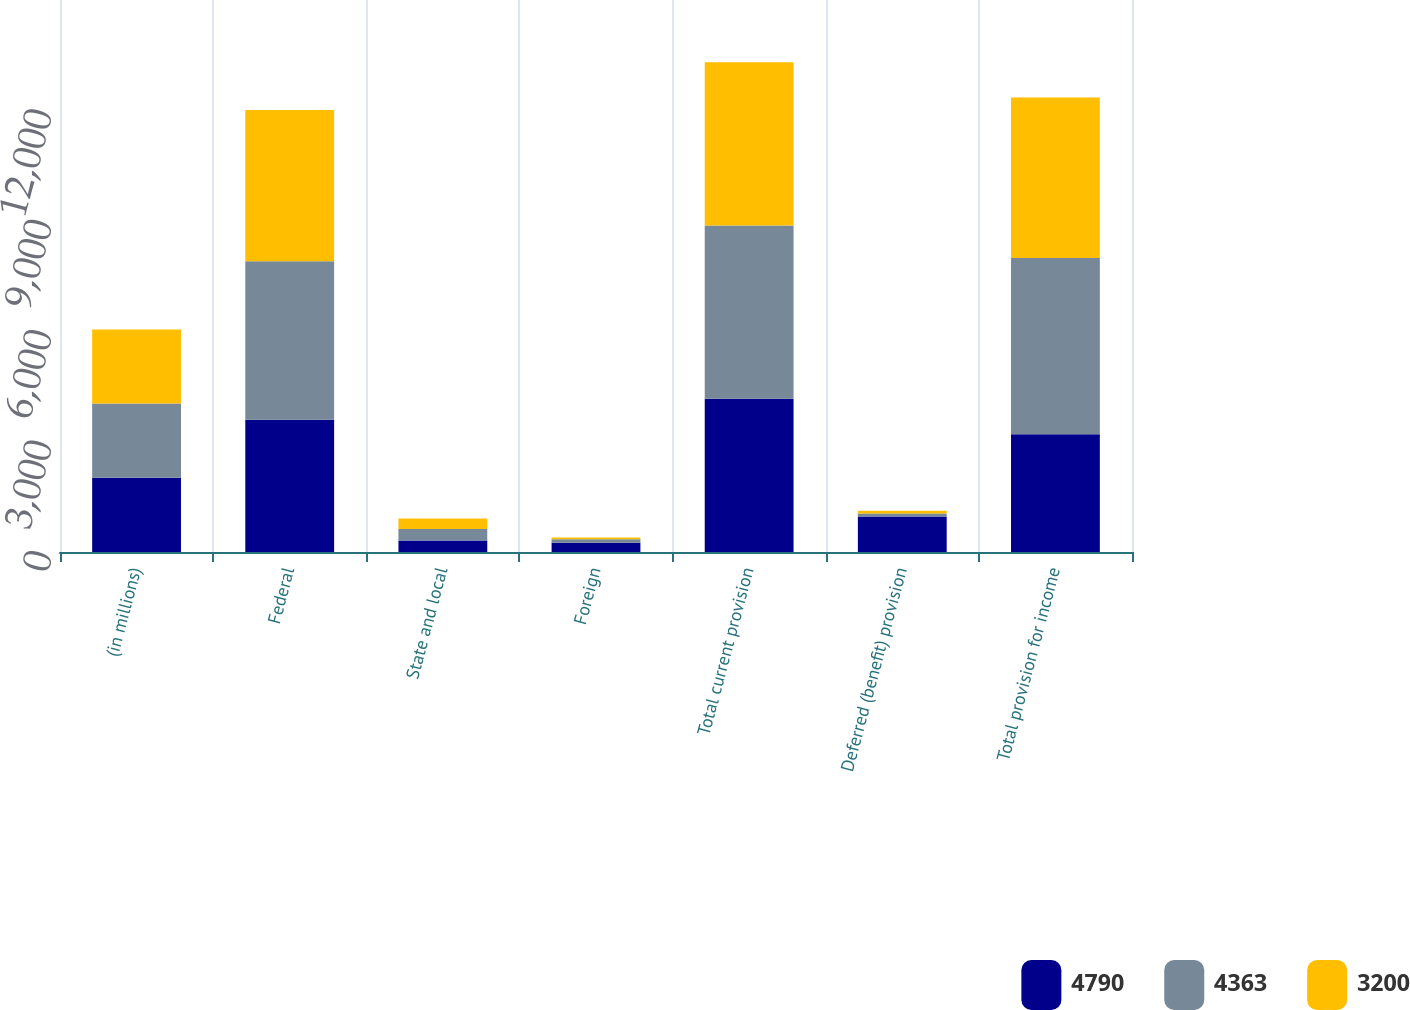<chart> <loc_0><loc_0><loc_500><loc_500><stacked_bar_chart><ecel><fcel>(in millions)<fcel>Federal<fcel>State and local<fcel>Foreign<fcel>Total current provision<fcel>Deferred (benefit) provision<fcel>Total provision for income<nl><fcel>4790<fcel>2017<fcel>3597<fcel>314<fcel>254<fcel>4165<fcel>965<fcel>3200<nl><fcel>4363<fcel>2016<fcel>4302<fcel>312<fcel>95<fcel>4709<fcel>81<fcel>4790<nl><fcel>3200<fcel>2015<fcel>4109<fcel>281<fcel>46<fcel>4436<fcel>73<fcel>4363<nl></chart> 